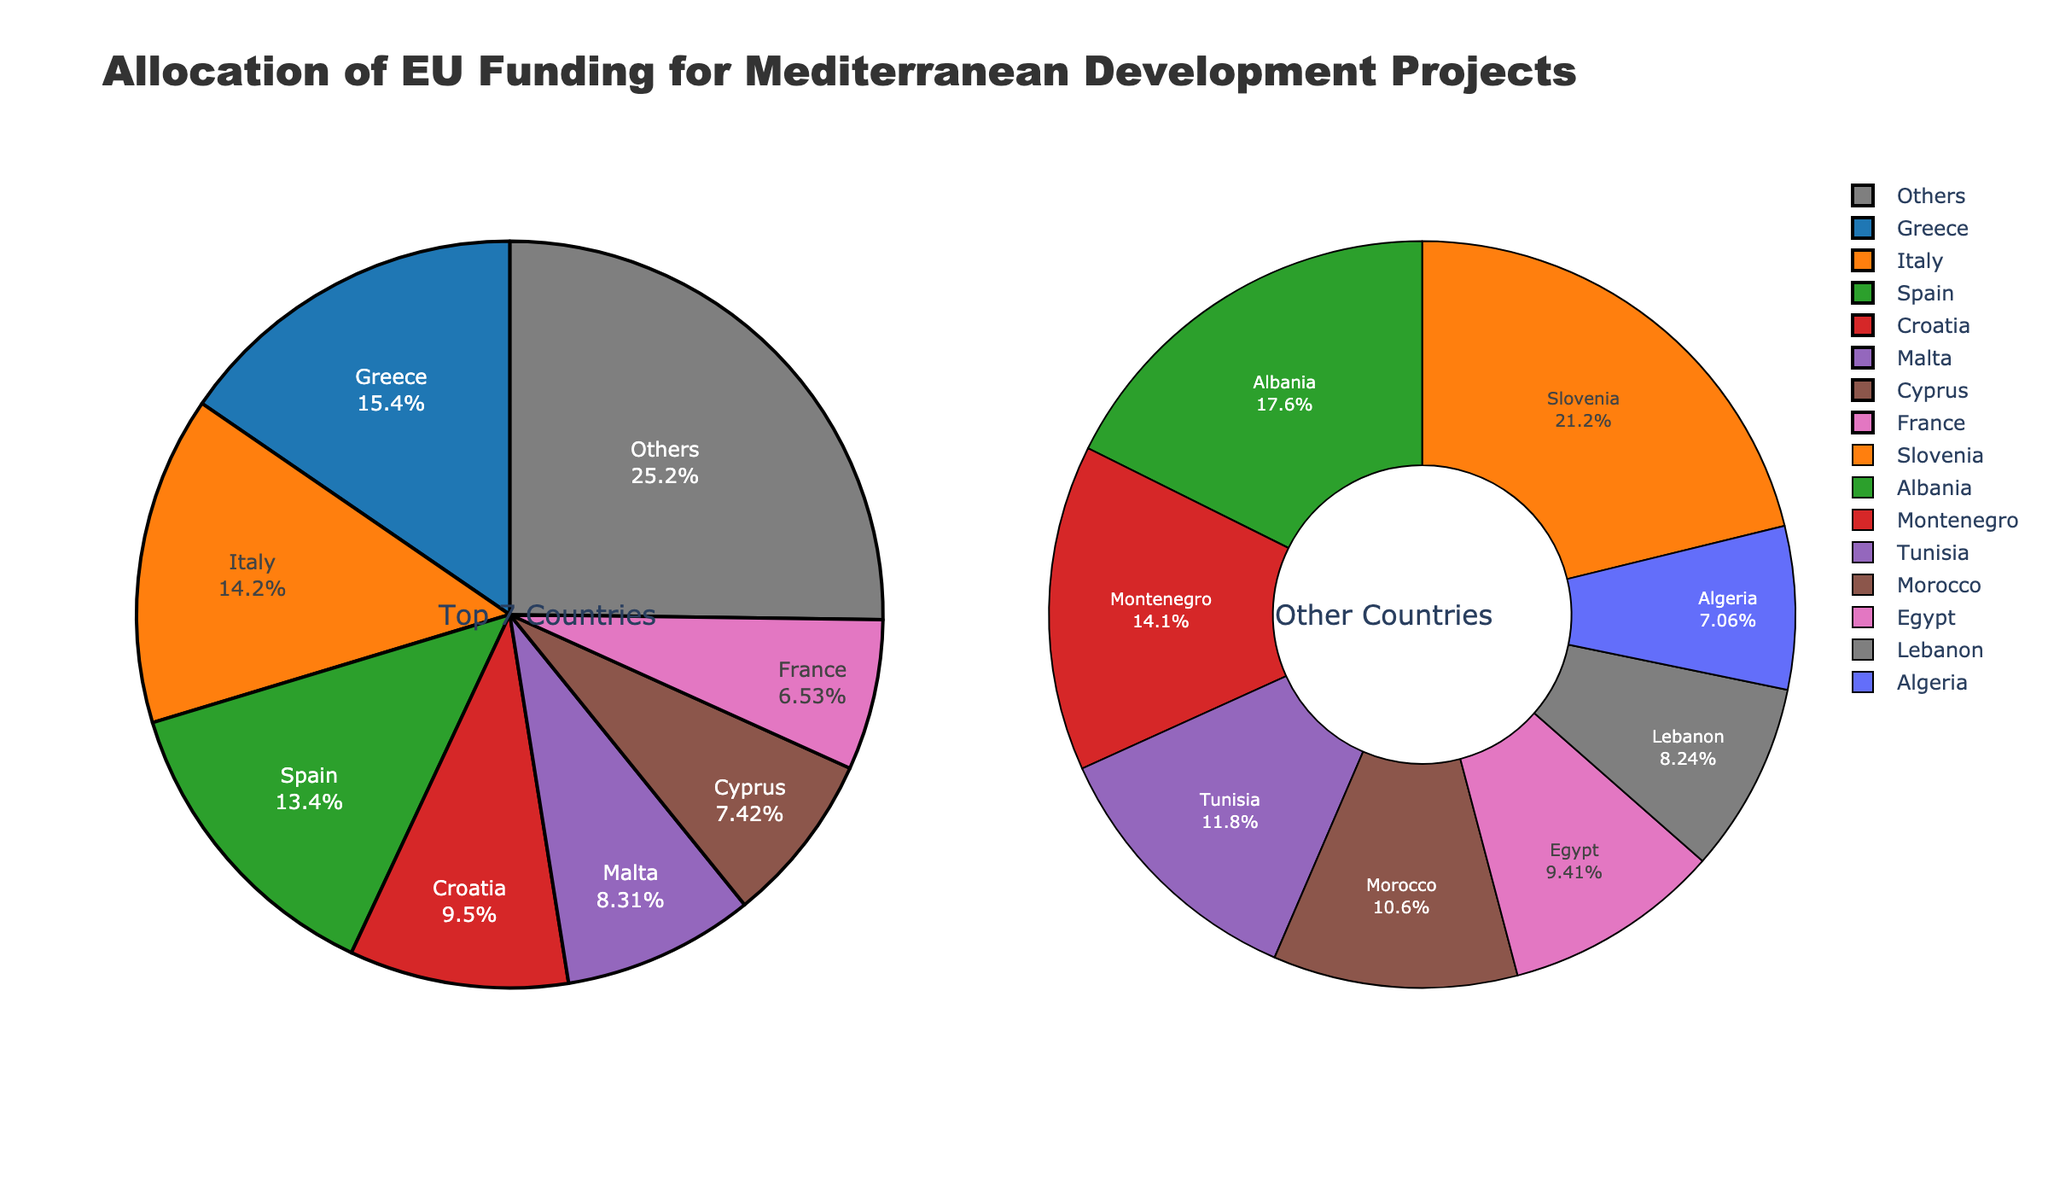Which country receives the largest allocation of EU funding for Mediterranean development projects? Greece receives the largest allocation. This is evident from the pie chart showing Greece as the segment with the highest value.
Answer: Greece Which two countries combined receive more funding than Spain? Italy and Croatia combined receive more funding than Spain. From the pie chart, Italy receives 480 million EUR and Croatia receives 320 million EUR, which totals 800 million EUR, compared to Spain's 450 million EUR.
Answer: Italy and Croatia What is the total funding allocated to Malta and Cyprus? The pie chart shows Malta receiving 280 million EUR and Cyprus receiving 250 million EUR. Adding these amounts gives a total of 530 million EUR.
Answer: 530 million EUR How does the funding allocation for Tunisia compare to that of Egypt? Tunisia receives 100 million EUR while Egypt receives 80 million EUR. Therefore, Tunisia receives more funding than Egypt.
Answer: Tunisia What percentage of the total funding does the "Others" category represent? The pie chart shows the "Others" category broken down separately, with the total amount being the sum of the countries labeled as "Others" excluding the top 7. From the bar colors and the summed breakdown, it represents the remaining allocation out of the total. Calculating the sum of the top 7, the "Others" category is the total minus this sum, which represents the remaining percentage in the pie chart.
Answer: Approximately 19.6% What is the approximate total funding allocation for the top 3 countries? Greece, Italy, and Spain are the top 3 countries. Greece receives 520 million EUR, Italy 480 million EUR, and Spain 450 million EUR. Summing these values yields 1450 million EUR.
Answer: 1450 million EUR Which country within the "Others" category receives the highest funding? From the chart breakdown of the "Others" category, France receives the highest funding at 220 million EUR.
Answer: France How does the funding for the top 7 countries visually compare to the "Others" category on the chart? The top 7 countries' funding is represented on the left half with larger individual segments, while the "Others" category on the right half comprises smaller segments combined to show the remaining countries. This visually indicates a larger, more significant portion for the top 7 countries.
Answer: Top 7 countries Which single visual element helps discern the "Others" category breakdown? The separate donut chart on the right side of the figure specifically displays the breakdown of the "Others" category, visually distinguishing it from the main pie chart.
Answer: Donut chart How much more funding does Greece receive in comparison to Malta? From the allocation amounts in the pie chart, Greece receives 520 million EUR and Malta receives 280 million EUR. The difference between these amounts is 240 million EUR.
Answer: 240 million EUR 